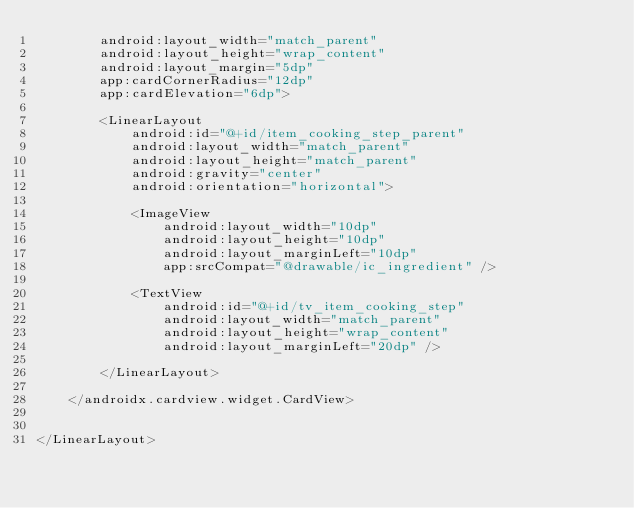<code> <loc_0><loc_0><loc_500><loc_500><_XML_>        android:layout_width="match_parent"
        android:layout_height="wrap_content"
        android:layout_margin="5dp"
        app:cardCornerRadius="12dp"
        app:cardElevation="6dp">

        <LinearLayout
            android:id="@+id/item_cooking_step_parent"
            android:layout_width="match_parent"
            android:layout_height="match_parent"
            android:gravity="center"
            android:orientation="horizontal">

            <ImageView
                android:layout_width="10dp"
                android:layout_height="10dp"
                android:layout_marginLeft="10dp"
                app:srcCompat="@drawable/ic_ingredient" />

            <TextView
                android:id="@+id/tv_item_cooking_step"
                android:layout_width="match_parent"
                android:layout_height="wrap_content"
                android:layout_marginLeft="20dp" />

        </LinearLayout>

    </androidx.cardview.widget.CardView>


</LinearLayout>
</code> 